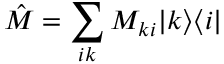<formula> <loc_0><loc_0><loc_500><loc_500>\hat { M } = \sum _ { i k } M _ { k i } | k \rangle \langle i |</formula> 